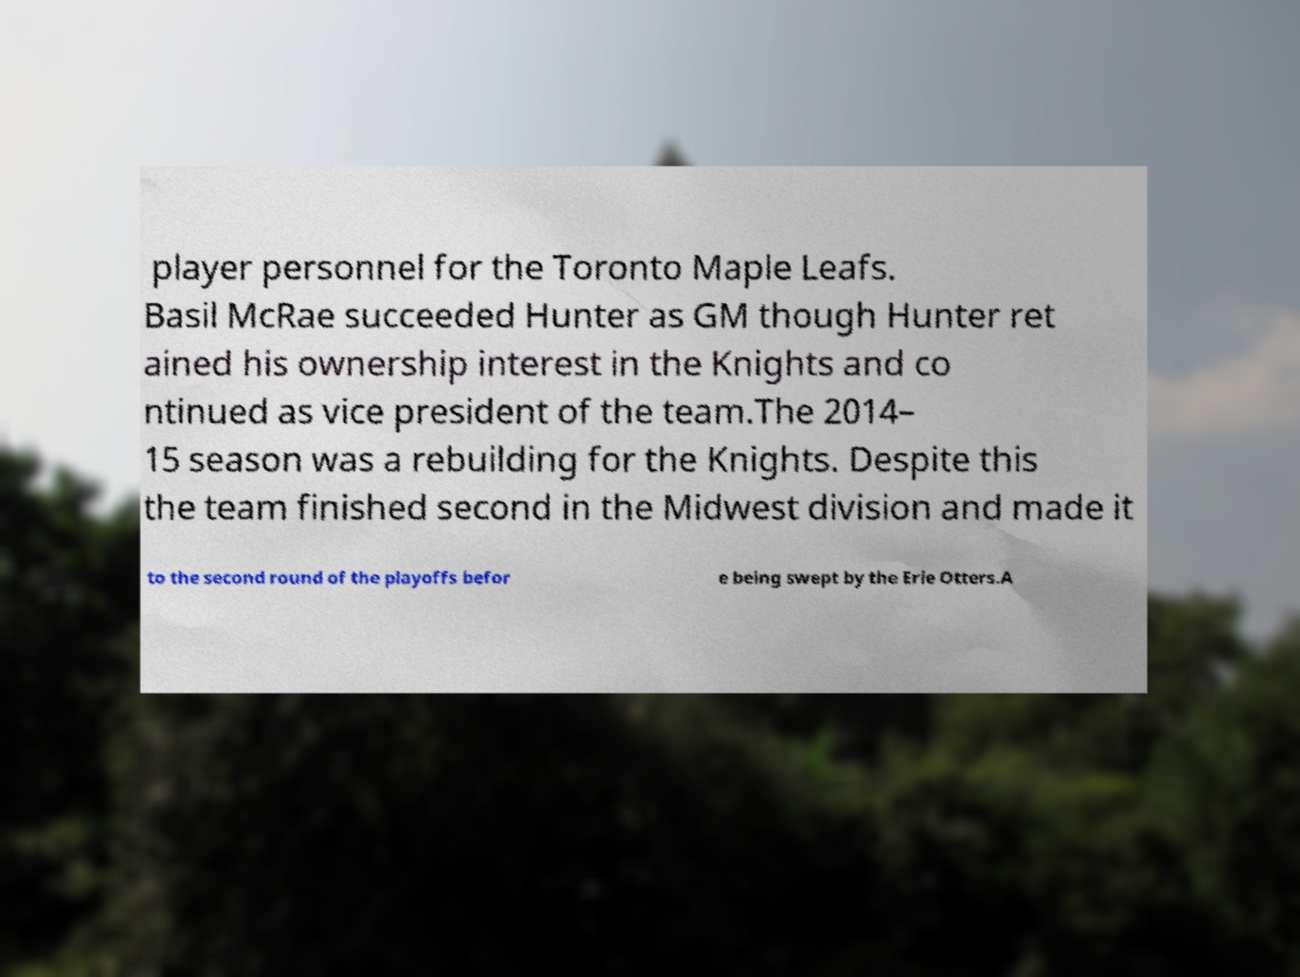Please read and relay the text visible in this image. What does it say? player personnel for the Toronto Maple Leafs. Basil McRae succeeded Hunter as GM though Hunter ret ained his ownership interest in the Knights and co ntinued as vice president of the team.The 2014– 15 season was a rebuilding for the Knights. Despite this the team finished second in the Midwest division and made it to the second round of the playoffs befor e being swept by the Erie Otters.A 